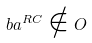<formula> <loc_0><loc_0><loc_500><loc_500>b a ^ { R C } \notin O</formula> 